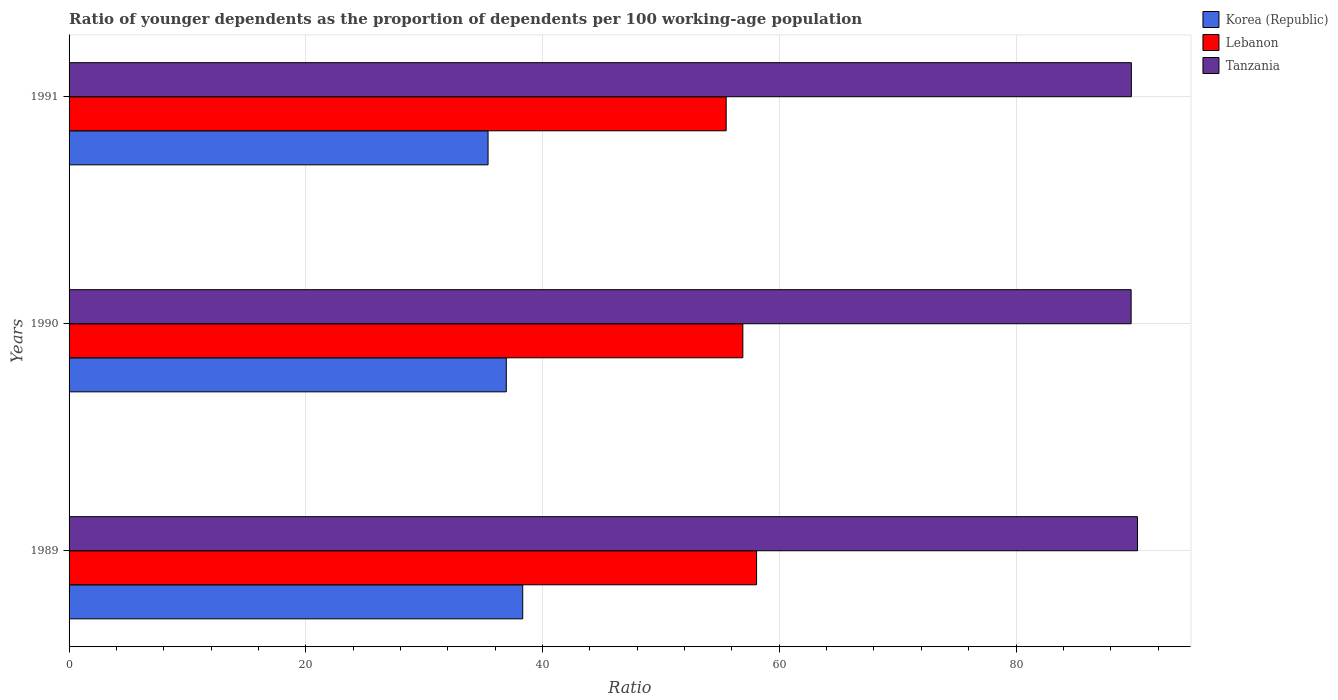How many groups of bars are there?
Your answer should be compact. 3. Are the number of bars per tick equal to the number of legend labels?
Your answer should be compact. Yes. Are the number of bars on each tick of the Y-axis equal?
Make the answer very short. Yes. What is the age dependency ratio(young) in Lebanon in 1989?
Offer a very short reply. 58.08. Across all years, what is the maximum age dependency ratio(young) in Tanzania?
Your response must be concise. 90.27. Across all years, what is the minimum age dependency ratio(young) in Lebanon?
Provide a succinct answer. 55.51. In which year was the age dependency ratio(young) in Lebanon maximum?
Your response must be concise. 1989. In which year was the age dependency ratio(young) in Tanzania minimum?
Your response must be concise. 1990. What is the total age dependency ratio(young) in Korea (Republic) in the graph?
Provide a short and direct response. 110.66. What is the difference between the age dependency ratio(young) in Tanzania in 1989 and that in 1990?
Give a very brief answer. 0.54. What is the difference between the age dependency ratio(young) in Korea (Republic) in 1990 and the age dependency ratio(young) in Lebanon in 1989?
Keep it short and to the point. -21.14. What is the average age dependency ratio(young) in Lebanon per year?
Keep it short and to the point. 56.84. In the year 1990, what is the difference between the age dependency ratio(young) in Tanzania and age dependency ratio(young) in Korea (Republic)?
Offer a terse response. 52.79. In how many years, is the age dependency ratio(young) in Korea (Republic) greater than 48 ?
Keep it short and to the point. 0. What is the ratio of the age dependency ratio(young) in Korea (Republic) in 1990 to that in 1991?
Provide a succinct answer. 1.04. Is the age dependency ratio(young) in Lebanon in 1989 less than that in 1991?
Your response must be concise. No. Is the difference between the age dependency ratio(young) in Tanzania in 1989 and 1991 greater than the difference between the age dependency ratio(young) in Korea (Republic) in 1989 and 1991?
Offer a very short reply. No. What is the difference between the highest and the second highest age dependency ratio(young) in Tanzania?
Offer a very short reply. 0.52. What is the difference between the highest and the lowest age dependency ratio(young) in Korea (Republic)?
Offer a terse response. 2.93. Is the sum of the age dependency ratio(young) in Lebanon in 1990 and 1991 greater than the maximum age dependency ratio(young) in Tanzania across all years?
Make the answer very short. Yes. What does the 1st bar from the top in 1989 represents?
Your answer should be compact. Tanzania. What does the 3rd bar from the bottom in 1991 represents?
Offer a very short reply. Tanzania. How many years are there in the graph?
Make the answer very short. 3. What is the difference between two consecutive major ticks on the X-axis?
Provide a short and direct response. 20. Does the graph contain grids?
Give a very brief answer. Yes. How are the legend labels stacked?
Make the answer very short. Vertical. What is the title of the graph?
Provide a short and direct response. Ratio of younger dependents as the proportion of dependents per 100 working-age population. Does "Middle East & North Africa (developing only)" appear as one of the legend labels in the graph?
Your answer should be very brief. No. What is the label or title of the X-axis?
Offer a terse response. Ratio. What is the Ratio in Korea (Republic) in 1989?
Offer a very short reply. 38.33. What is the Ratio of Lebanon in 1989?
Your response must be concise. 58.08. What is the Ratio in Tanzania in 1989?
Ensure brevity in your answer.  90.27. What is the Ratio in Korea (Republic) in 1990?
Offer a very short reply. 36.94. What is the Ratio in Lebanon in 1990?
Your answer should be very brief. 56.92. What is the Ratio in Tanzania in 1990?
Provide a succinct answer. 89.73. What is the Ratio in Korea (Republic) in 1991?
Give a very brief answer. 35.4. What is the Ratio in Lebanon in 1991?
Ensure brevity in your answer.  55.51. What is the Ratio of Tanzania in 1991?
Offer a very short reply. 89.75. Across all years, what is the maximum Ratio of Korea (Republic)?
Your answer should be compact. 38.33. Across all years, what is the maximum Ratio in Lebanon?
Your answer should be compact. 58.08. Across all years, what is the maximum Ratio in Tanzania?
Your answer should be compact. 90.27. Across all years, what is the minimum Ratio in Korea (Republic)?
Give a very brief answer. 35.4. Across all years, what is the minimum Ratio of Lebanon?
Offer a very short reply. 55.51. Across all years, what is the minimum Ratio of Tanzania?
Offer a terse response. 89.73. What is the total Ratio of Korea (Republic) in the graph?
Make the answer very short. 110.66. What is the total Ratio of Lebanon in the graph?
Your answer should be very brief. 170.52. What is the total Ratio in Tanzania in the graph?
Your answer should be very brief. 269.74. What is the difference between the Ratio of Korea (Republic) in 1989 and that in 1990?
Your response must be concise. 1.39. What is the difference between the Ratio of Lebanon in 1989 and that in 1990?
Provide a short and direct response. 1.16. What is the difference between the Ratio in Tanzania in 1989 and that in 1990?
Ensure brevity in your answer.  0.54. What is the difference between the Ratio of Korea (Republic) in 1989 and that in 1991?
Provide a succinct answer. 2.93. What is the difference between the Ratio of Lebanon in 1989 and that in 1991?
Give a very brief answer. 2.57. What is the difference between the Ratio of Tanzania in 1989 and that in 1991?
Provide a short and direct response. 0.52. What is the difference between the Ratio of Korea (Republic) in 1990 and that in 1991?
Offer a terse response. 1.54. What is the difference between the Ratio in Lebanon in 1990 and that in 1991?
Provide a short and direct response. 1.41. What is the difference between the Ratio in Tanzania in 1990 and that in 1991?
Give a very brief answer. -0.02. What is the difference between the Ratio of Korea (Republic) in 1989 and the Ratio of Lebanon in 1990?
Offer a terse response. -18.6. What is the difference between the Ratio of Korea (Republic) in 1989 and the Ratio of Tanzania in 1990?
Offer a terse response. -51.4. What is the difference between the Ratio of Lebanon in 1989 and the Ratio of Tanzania in 1990?
Ensure brevity in your answer.  -31.64. What is the difference between the Ratio of Korea (Republic) in 1989 and the Ratio of Lebanon in 1991?
Your answer should be compact. -17.19. What is the difference between the Ratio in Korea (Republic) in 1989 and the Ratio in Tanzania in 1991?
Provide a short and direct response. -51.42. What is the difference between the Ratio in Lebanon in 1989 and the Ratio in Tanzania in 1991?
Offer a very short reply. -31.66. What is the difference between the Ratio in Korea (Republic) in 1990 and the Ratio in Lebanon in 1991?
Offer a terse response. -18.58. What is the difference between the Ratio in Korea (Republic) in 1990 and the Ratio in Tanzania in 1991?
Provide a short and direct response. -52.81. What is the difference between the Ratio of Lebanon in 1990 and the Ratio of Tanzania in 1991?
Your answer should be very brief. -32.82. What is the average Ratio of Korea (Republic) per year?
Provide a succinct answer. 36.89. What is the average Ratio in Lebanon per year?
Offer a very short reply. 56.84. What is the average Ratio of Tanzania per year?
Keep it short and to the point. 89.91. In the year 1989, what is the difference between the Ratio in Korea (Republic) and Ratio in Lebanon?
Keep it short and to the point. -19.76. In the year 1989, what is the difference between the Ratio in Korea (Republic) and Ratio in Tanzania?
Give a very brief answer. -51.94. In the year 1989, what is the difference between the Ratio in Lebanon and Ratio in Tanzania?
Your response must be concise. -32.18. In the year 1990, what is the difference between the Ratio in Korea (Republic) and Ratio in Lebanon?
Give a very brief answer. -19.98. In the year 1990, what is the difference between the Ratio of Korea (Republic) and Ratio of Tanzania?
Ensure brevity in your answer.  -52.79. In the year 1990, what is the difference between the Ratio of Lebanon and Ratio of Tanzania?
Keep it short and to the point. -32.8. In the year 1991, what is the difference between the Ratio in Korea (Republic) and Ratio in Lebanon?
Offer a very short reply. -20.12. In the year 1991, what is the difference between the Ratio of Korea (Republic) and Ratio of Tanzania?
Ensure brevity in your answer.  -54.35. In the year 1991, what is the difference between the Ratio in Lebanon and Ratio in Tanzania?
Offer a very short reply. -34.23. What is the ratio of the Ratio in Korea (Republic) in 1989 to that in 1990?
Ensure brevity in your answer.  1.04. What is the ratio of the Ratio of Lebanon in 1989 to that in 1990?
Offer a very short reply. 1.02. What is the ratio of the Ratio in Korea (Republic) in 1989 to that in 1991?
Your answer should be compact. 1.08. What is the ratio of the Ratio in Lebanon in 1989 to that in 1991?
Provide a succinct answer. 1.05. What is the ratio of the Ratio in Korea (Republic) in 1990 to that in 1991?
Make the answer very short. 1.04. What is the ratio of the Ratio of Lebanon in 1990 to that in 1991?
Your answer should be very brief. 1.03. What is the difference between the highest and the second highest Ratio in Korea (Republic)?
Offer a very short reply. 1.39. What is the difference between the highest and the second highest Ratio of Lebanon?
Make the answer very short. 1.16. What is the difference between the highest and the second highest Ratio of Tanzania?
Provide a short and direct response. 0.52. What is the difference between the highest and the lowest Ratio of Korea (Republic)?
Offer a terse response. 2.93. What is the difference between the highest and the lowest Ratio in Lebanon?
Offer a terse response. 2.57. What is the difference between the highest and the lowest Ratio of Tanzania?
Your answer should be very brief. 0.54. 